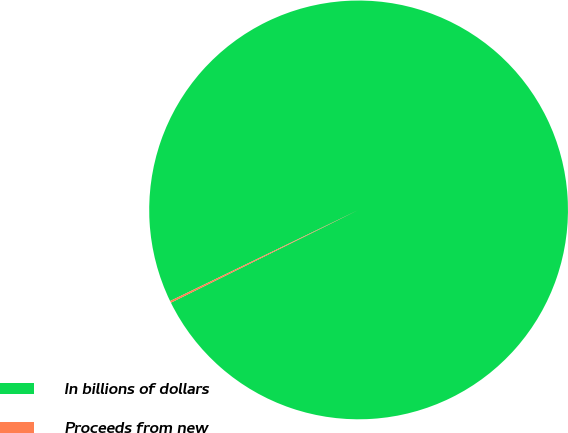Convert chart to OTSL. <chart><loc_0><loc_0><loc_500><loc_500><pie_chart><fcel>In billions of dollars<fcel>Proceeds from new<nl><fcel>99.86%<fcel>0.14%<nl></chart> 